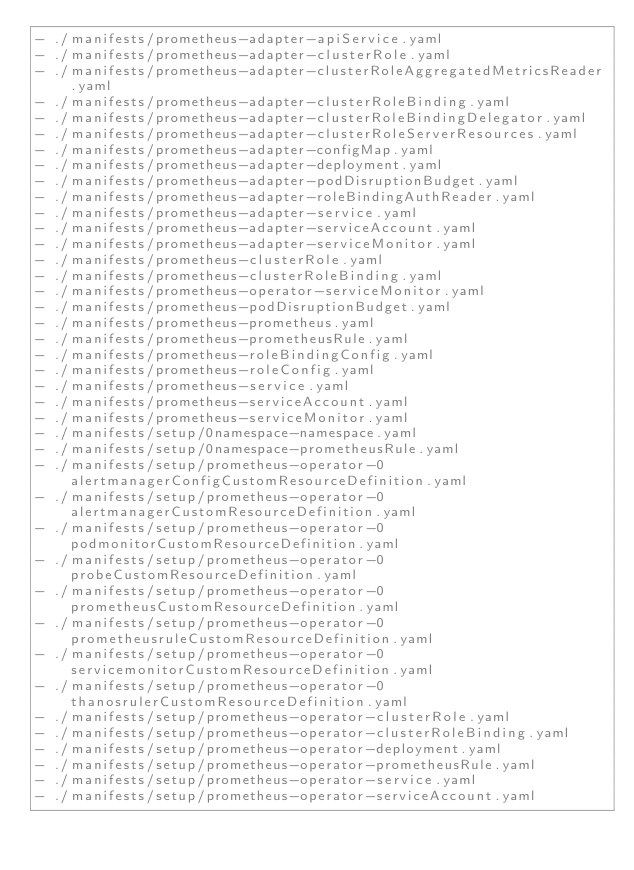<code> <loc_0><loc_0><loc_500><loc_500><_YAML_>- ./manifests/prometheus-adapter-apiService.yaml
- ./manifests/prometheus-adapter-clusterRole.yaml
- ./manifests/prometheus-adapter-clusterRoleAggregatedMetricsReader.yaml
- ./manifests/prometheus-adapter-clusterRoleBinding.yaml
- ./manifests/prometheus-adapter-clusterRoleBindingDelegator.yaml
- ./manifests/prometheus-adapter-clusterRoleServerResources.yaml
- ./manifests/prometheus-adapter-configMap.yaml
- ./manifests/prometheus-adapter-deployment.yaml
- ./manifests/prometheus-adapter-podDisruptionBudget.yaml
- ./manifests/prometheus-adapter-roleBindingAuthReader.yaml
- ./manifests/prometheus-adapter-service.yaml
- ./manifests/prometheus-adapter-serviceAccount.yaml
- ./manifests/prometheus-adapter-serviceMonitor.yaml
- ./manifests/prometheus-clusterRole.yaml
- ./manifests/prometheus-clusterRoleBinding.yaml
- ./manifests/prometheus-operator-serviceMonitor.yaml
- ./manifests/prometheus-podDisruptionBudget.yaml
- ./manifests/prometheus-prometheus.yaml
- ./manifests/prometheus-prometheusRule.yaml
- ./manifests/prometheus-roleBindingConfig.yaml
- ./manifests/prometheus-roleConfig.yaml
- ./manifests/prometheus-service.yaml
- ./manifests/prometheus-serviceAccount.yaml
- ./manifests/prometheus-serviceMonitor.yaml
- ./manifests/setup/0namespace-namespace.yaml
- ./manifests/setup/0namespace-prometheusRule.yaml
- ./manifests/setup/prometheus-operator-0alertmanagerConfigCustomResourceDefinition.yaml
- ./manifests/setup/prometheus-operator-0alertmanagerCustomResourceDefinition.yaml
- ./manifests/setup/prometheus-operator-0podmonitorCustomResourceDefinition.yaml
- ./manifests/setup/prometheus-operator-0probeCustomResourceDefinition.yaml
- ./manifests/setup/prometheus-operator-0prometheusCustomResourceDefinition.yaml
- ./manifests/setup/prometheus-operator-0prometheusruleCustomResourceDefinition.yaml
- ./manifests/setup/prometheus-operator-0servicemonitorCustomResourceDefinition.yaml
- ./manifests/setup/prometheus-operator-0thanosrulerCustomResourceDefinition.yaml
- ./manifests/setup/prometheus-operator-clusterRole.yaml
- ./manifests/setup/prometheus-operator-clusterRoleBinding.yaml
- ./manifests/setup/prometheus-operator-deployment.yaml
- ./manifests/setup/prometheus-operator-prometheusRule.yaml
- ./manifests/setup/prometheus-operator-service.yaml
- ./manifests/setup/prometheus-operator-serviceAccount.yaml
</code> 